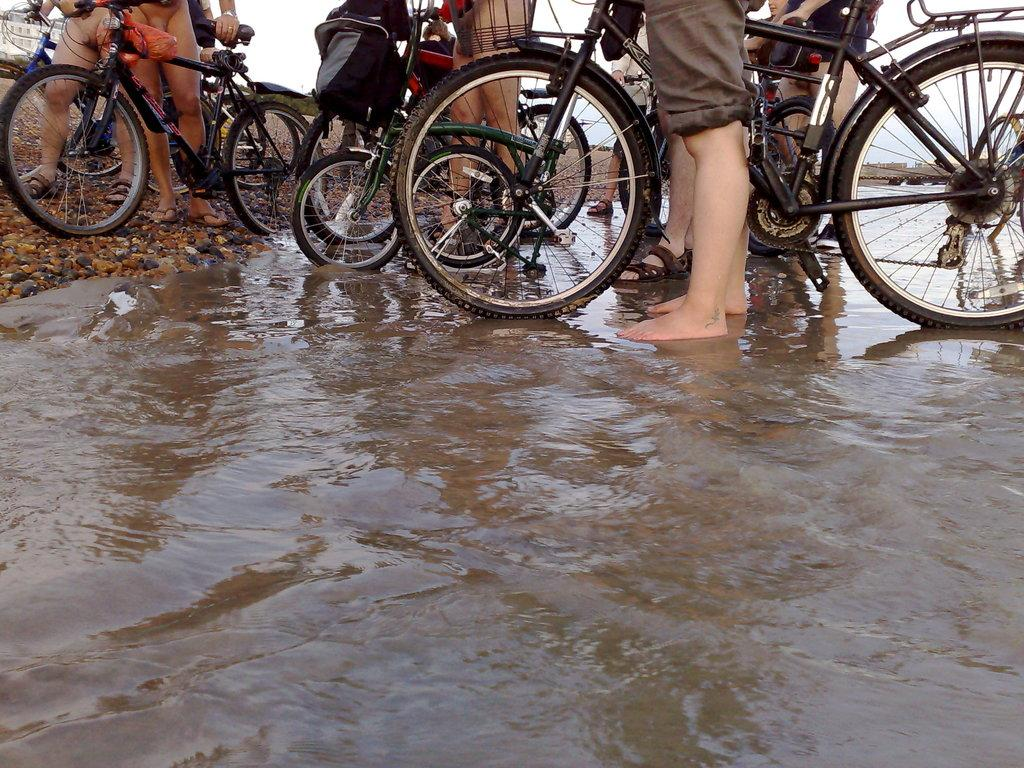What are the persons in the image holding? The persons in the image are holding bicycles. Where are some of the persons standing? Some persons are standing on the ground, while others are standing on the water. What can be seen in the background of the image? There is sky visible in the background of the image. What type of tail can be seen on the bicycles in the image? There are no tails present on the bicycles in the image. How many persons have died while holding bicycles in the image? There is no information about any deaths in the image; it simply shows persons holding bicycles. 